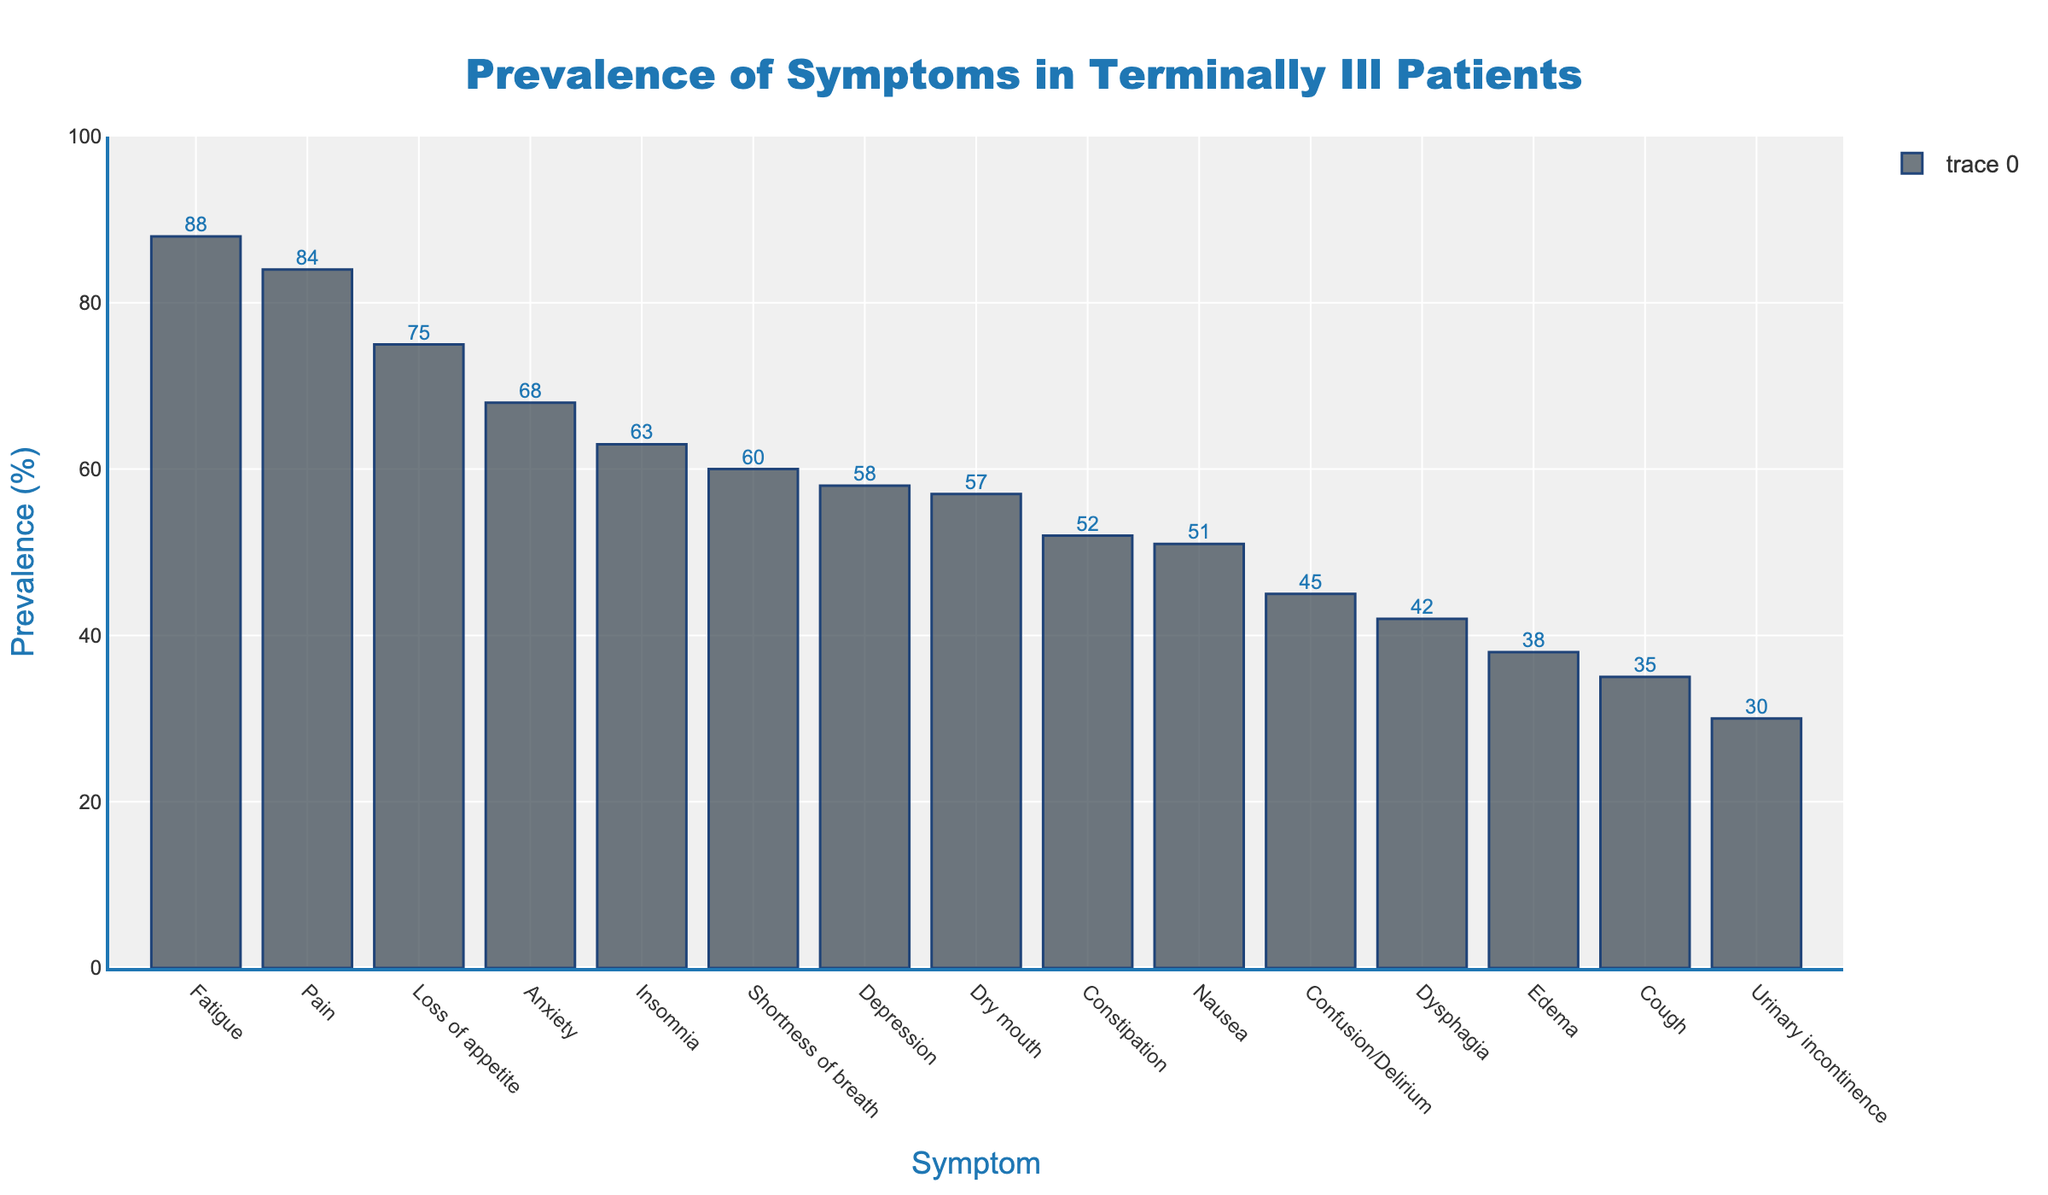What is the most prevalent symptom in terminally ill patients? The highest bar in the chart represents the symptom with the highest prevalence. Here, the bar for Fatigue is the tallest with a prevalence of 88%.
Answer: Fatigue Which symptom has a higher prevalence, Anxiety or Depression? Comparing the heights of the bars for Anxiety and Depression, the bar for Anxiety is higher with a prevalence of 68%, whereas the bar for Depression has 58%.
Answer: Anxiety What is the prevalence difference between Nausea and Constipation? The prevalence of Nausea is 51% and the prevalence of Constipation is 52%. The difference is 52% - 51% = 1%.
Answer: 1% How many symptoms have a prevalence higher than 60%? By examining the bar heights, the symptoms with prevalence higher than 60% are Fatigue (88%), Pain (84%), Anxiety (68%), Insomnia (63%), and Shortness of breath (60%). Count these symptoms to get 5.
Answer: 5 What is the combined prevalence of Pain, Fatigue, and Shortness of breath? The prevalences are 84% for Pain, 88% for Fatigue, and 60% for Shortness of breath. Adding these together, 84 + 88 + 60 = 232%.
Answer: 232% Is the prevalence of Dry mouth higher or lower than Loss of appetite? The bar for Dry mouth shows a prevalence of 57%, whereas the bar for Loss of appetite shows 75%. Thus, Dry mouth has a lower prevalence.
Answer: Lower What is the average prevalence of Nausea, Cough, and Dysphagia? The prevalences are 51% for Nausea, 35% for Cough, and 42% for Dysphagia. The sum is 51 + 35 + 42 = 128%, and the average is 128 / 3 = 42.67%.
Answer: 42.67% Which symptom has the lowest prevalence, and what is it? The shortest bar in the chart corresponds to the symptom with the lowest prevalence. Here, the bar for Urinary incontinence is the shortest with a prevalence of 30%.
Answer: Urinary incontinence Between Insomnia and Confusion/Delirium, which symptom has a lower prevalence and by how much? The prevalence of Insomnia is 63% and that of Confusion/Delirium is 45%. The difference is 63% - 45% = 18%. Hence, Confusion/Delirium is lower by 18%.
Answer: Confusion/Delirium, 18% What is the median prevalence of all listed symptoms? To find the median, list the prevalences in ascending order: 30, 35, 38, 42, 45, 51, 52, 57, 58, 60, 63, 68, 75, 84, 88. The median is the middle value in this ordered list, which is 57%.
Answer: 57% 